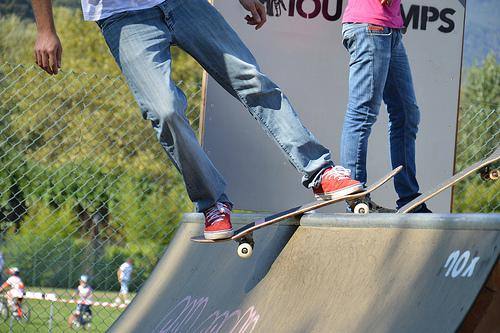Question: who is in the picture's foreground?
Choices:
A. A young man.
B. A skater.
C. A girl.
D. A boy.
Answer with the letter. Answer: B Question: what is the skater doing?
Choices:
A. Riding a rail.
B. Pushing himself.
C. Jumping a ramp.
D. Doing a trick.
Answer with the letter. Answer: C Question: how is the weather?
Choices:
A. Cloudy.
B. Raining.
C. Warm.
D. Sunny.
Answer with the letter. Answer: D Question: what is in the background?
Choices:
A. A tree.
B. Flowers.
C. A fence.
D. A building.
Answer with the letter. Answer: C 